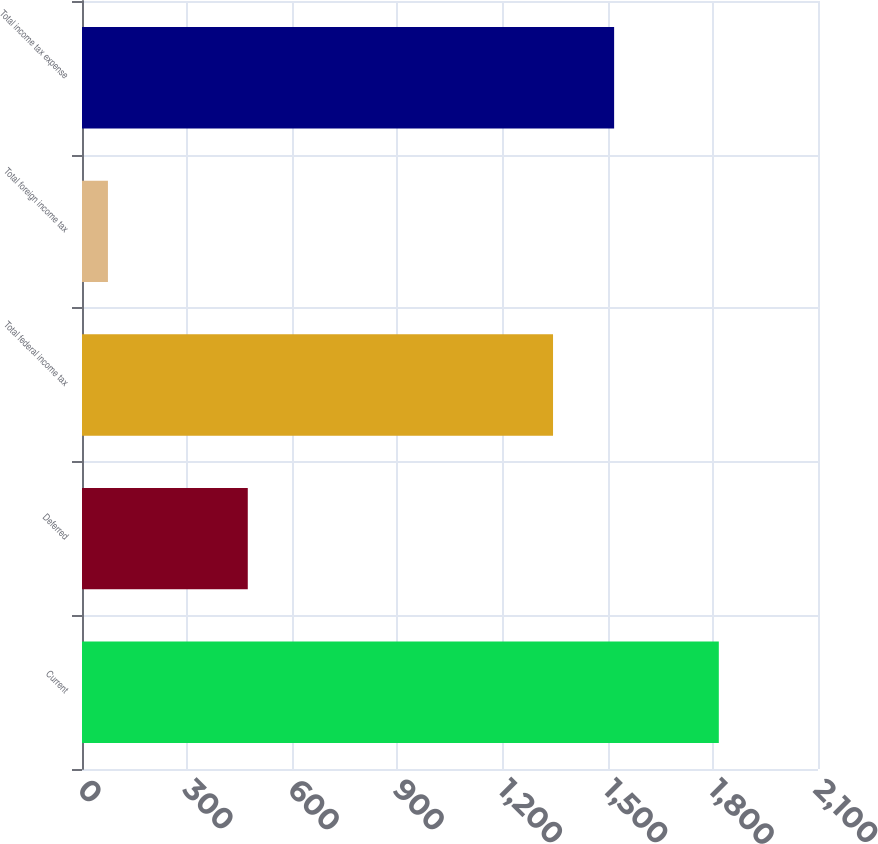Convert chart to OTSL. <chart><loc_0><loc_0><loc_500><loc_500><bar_chart><fcel>Current<fcel>Deferred<fcel>Total federal income tax<fcel>Total foreign income tax<fcel>Total income tax expense<nl><fcel>1817<fcel>473<fcel>1344<fcel>74<fcel>1518.3<nl></chart> 